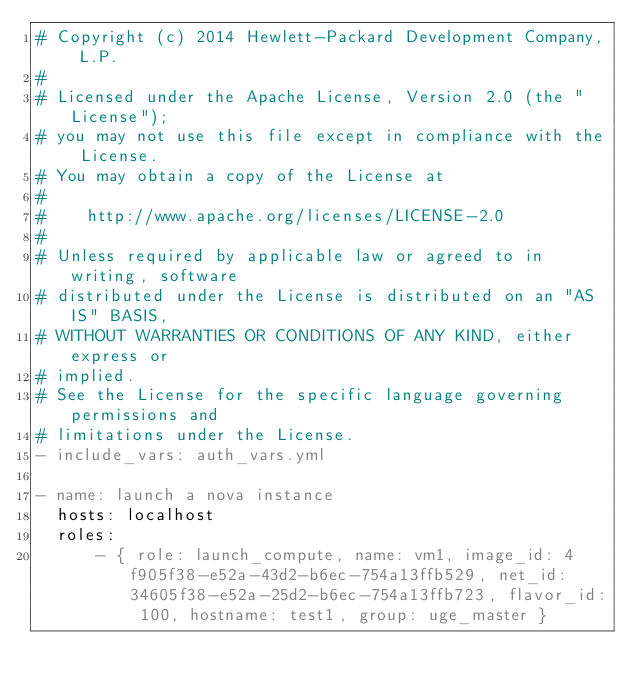<code> <loc_0><loc_0><loc_500><loc_500><_YAML_># Copyright (c) 2014 Hewlett-Packard Development Company, L.P.
#
# Licensed under the Apache License, Version 2.0 (the "License");
# you may not use this file except in compliance with the License.
# You may obtain a copy of the License at
#
#    http://www.apache.org/licenses/LICENSE-2.0
#
# Unless required by applicable law or agreed to in writing, software
# distributed under the License is distributed on an "AS IS" BASIS,
# WITHOUT WARRANTIES OR CONDITIONS OF ANY KIND, either express or
# implied.
# See the License for the specific language governing permissions and
# limitations under the License.
- include_vars: auth_vars.yml

- name: launch a nova instance
  hosts: localhost
  roles:
      - { role: launch_compute, name: vm1, image_id: 4f905f38-e52a-43d2-b6ec-754a13ffb529, net_id: 34605f38-e52a-25d2-b6ec-754a13ffb723, flavor_id: 100, hostname: test1, group: uge_master }
</code> 